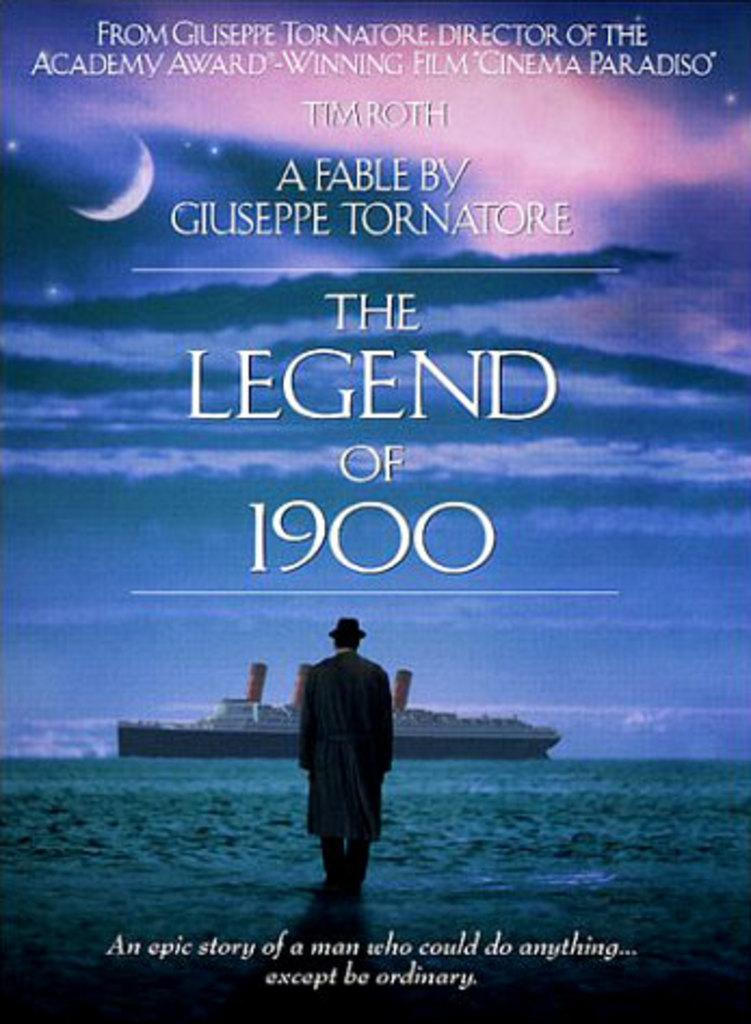<image>
Relay a brief, clear account of the picture shown. Tim Roth stars in a film called The Legend of 1900. 